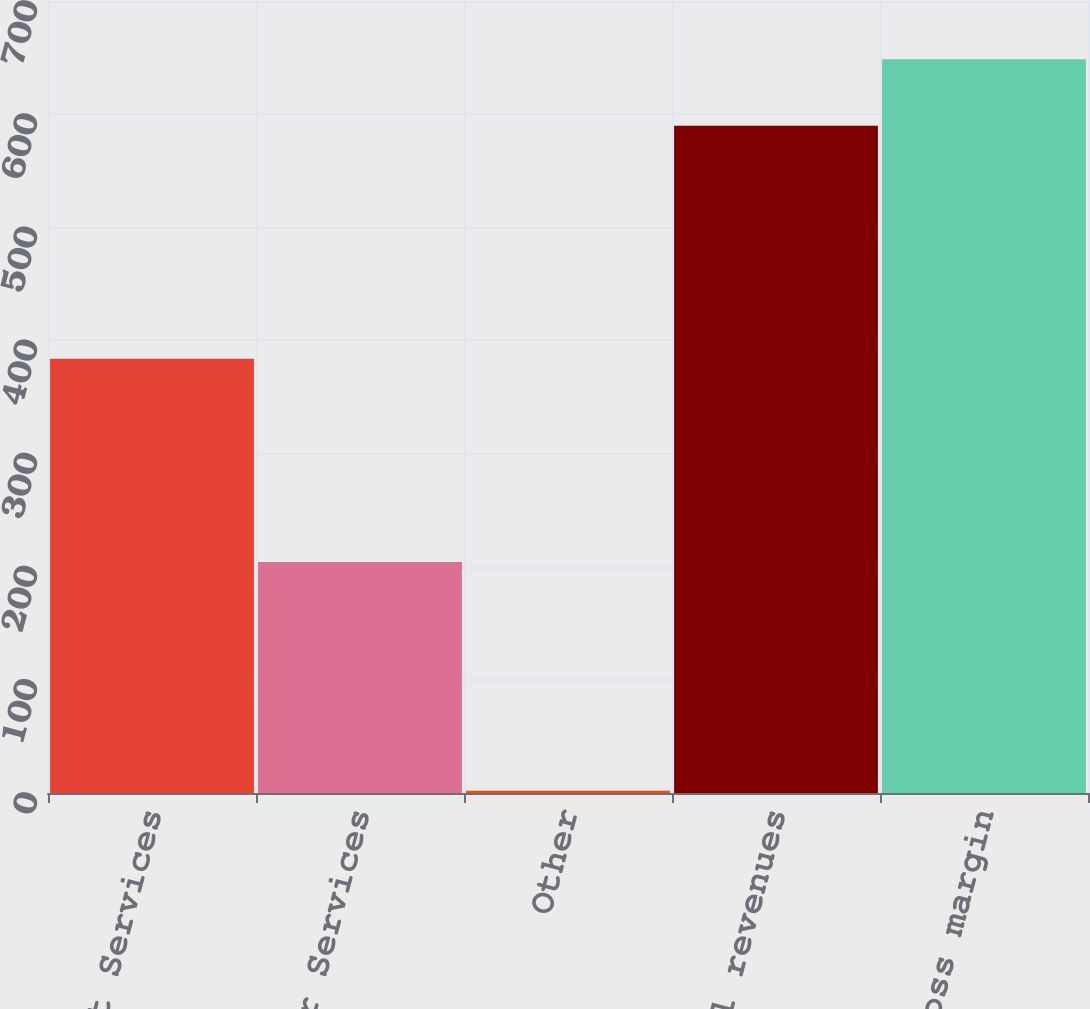Convert chart to OTSL. <chart><loc_0><loc_0><loc_500><loc_500><bar_chart><fcel>Market Services<fcel>Issuer Services<fcel>Other<fcel>Total revenues<fcel>Gross margin<nl><fcel>383.7<fcel>204.2<fcel>1.9<fcel>589.8<fcel>648.59<nl></chart> 